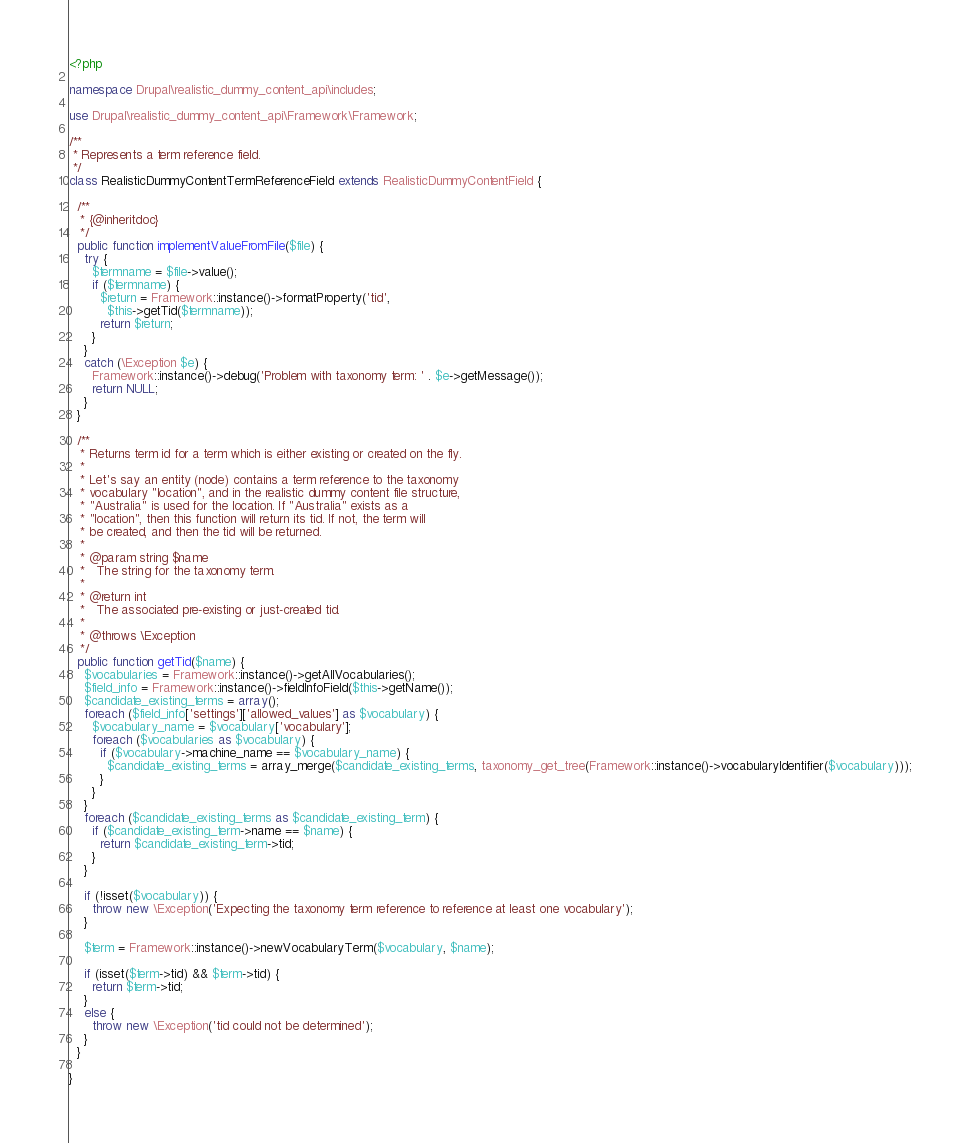Convert code to text. <code><loc_0><loc_0><loc_500><loc_500><_PHP_><?php

namespace Drupal\realistic_dummy_content_api\includes;

use Drupal\realistic_dummy_content_api\Framework\Framework;

/**
 * Represents a term reference field.
 */
class RealisticDummyContentTermReferenceField extends RealisticDummyContentField {

  /**
   * {@inheritdoc}
   */
  public function implementValueFromFile($file) {
    try {
      $termname = $file->value();
      if ($termname) {
        $return = Framework::instance()->formatProperty('tid',
          $this->getTid($termname));
        return $return;
      }
    }
    catch (\Exception $e) {
      Framework::instance()->debug('Problem with taxonomy term: ' . $e->getMessage());
      return NULL;
    }
  }

  /**
   * Returns term id for a term which is either existing or created on the fly.
   *
   * Let's say an entity (node) contains a term reference to the taxonomy
   * vocabulary "location", and in the realistic dummy content file structure,
   * "Australia" is used for the location. If "Australia" exists as a
   * "location", then this function will return its tid. If not, the term will
   * be created, and then the tid will be returned.
   *
   * @param string $name
   *   The string for the taxonomy term.
   *
   * @return int
   *   The associated pre-existing or just-created tid.
   *
   * @throws \Exception
   */
  public function getTid($name) {
    $vocabularies = Framework::instance()->getAllVocabularies();
    $field_info = Framework::instance()->fieldInfoField($this->getName());
    $candidate_existing_terms = array();
    foreach ($field_info['settings']['allowed_values'] as $vocabulary) {
      $vocabulary_name = $vocabulary['vocabulary'];
      foreach ($vocabularies as $vocabulary) {
        if ($vocabulary->machine_name == $vocabulary_name) {
          $candidate_existing_terms = array_merge($candidate_existing_terms, taxonomy_get_tree(Framework::instance()->vocabularyIdentifier($vocabulary)));
        }
      }
    }
    foreach ($candidate_existing_terms as $candidate_existing_term) {
      if ($candidate_existing_term->name == $name) {
        return $candidate_existing_term->tid;
      }
    }

    if (!isset($vocabulary)) {
      throw new \Exception('Expecting the taxonomy term reference to reference at least one vocabulary');
    }

    $term = Framework::instance()->newVocabularyTerm($vocabulary, $name);

    if (isset($term->tid) && $term->tid) {
      return $term->tid;
    }
    else {
      throw new \Exception('tid could not be determined');
    }
  }

}
</code> 